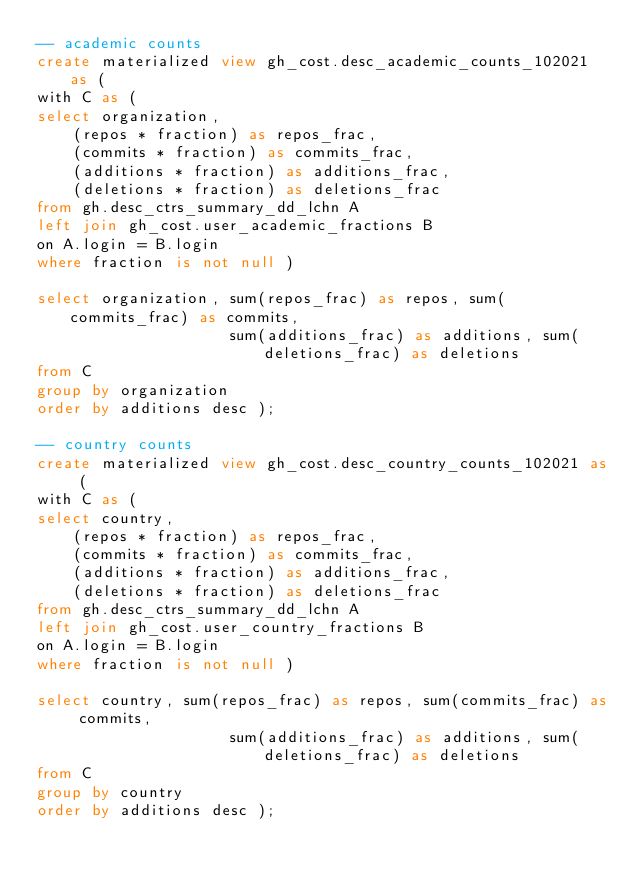<code> <loc_0><loc_0><loc_500><loc_500><_SQL_>-- academic counts
create materialized view gh_cost.desc_academic_counts_102021 as (
with C as (
select organization,
	(repos * fraction) as repos_frac,
	(commits * fraction) as commits_frac,
	(additions * fraction) as additions_frac,
	(deletions * fraction) as deletions_frac
from gh.desc_ctrs_summary_dd_lchn A
left join gh_cost.user_academic_fractions B
on A.login = B.login
where fraction is not null )

select organization, sum(repos_frac) as repos, sum(commits_frac) as commits,
					 sum(additions_frac) as additions, sum(deletions_frac) as deletions
from C
group by organization
order by additions desc );

-- country counts
create materialized view gh_cost.desc_country_counts_102021 as (
with C as (
select country,
	(repos * fraction) as repos_frac,
	(commits * fraction) as commits_frac,
	(additions * fraction) as additions_frac,
	(deletions * fraction) as deletions_frac
from gh.desc_ctrs_summary_dd_lchn A
left join gh_cost.user_country_fractions B
on A.login = B.login
where fraction is not null )

select country, sum(repos_frac) as repos, sum(commits_frac) as commits,
					 sum(additions_frac) as additions, sum(deletions_frac) as deletions
from C
group by country
order by additions desc );
</code> 